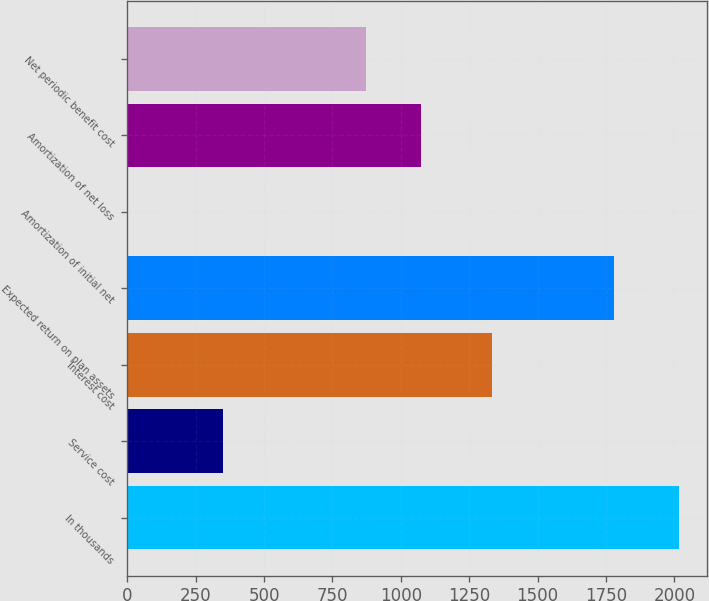<chart> <loc_0><loc_0><loc_500><loc_500><bar_chart><fcel>In thousands<fcel>Service cost<fcel>Interest cost<fcel>Expected return on plan assets<fcel>Amortization of initial net<fcel>Amortization of net loss<fcel>Net periodic benefit cost<nl><fcel>2018<fcel>349<fcel>1332<fcel>1780<fcel>3<fcel>1075.5<fcel>874<nl></chart> 